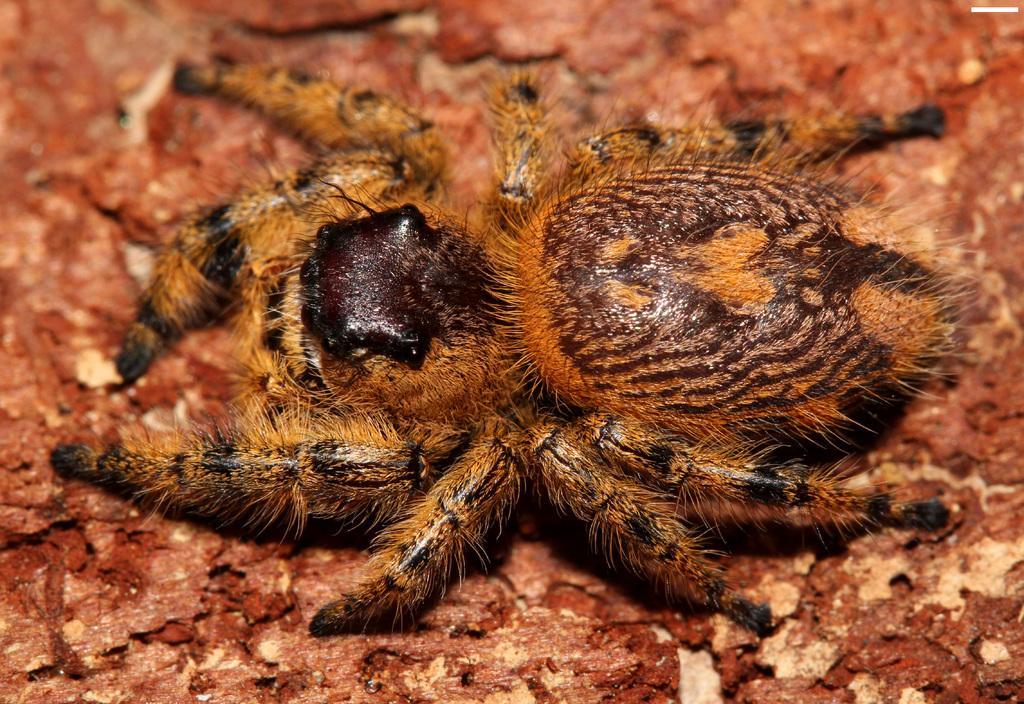How would you summarize this image in a sentence or two? In the picture I can see a spider on a red color surface. 